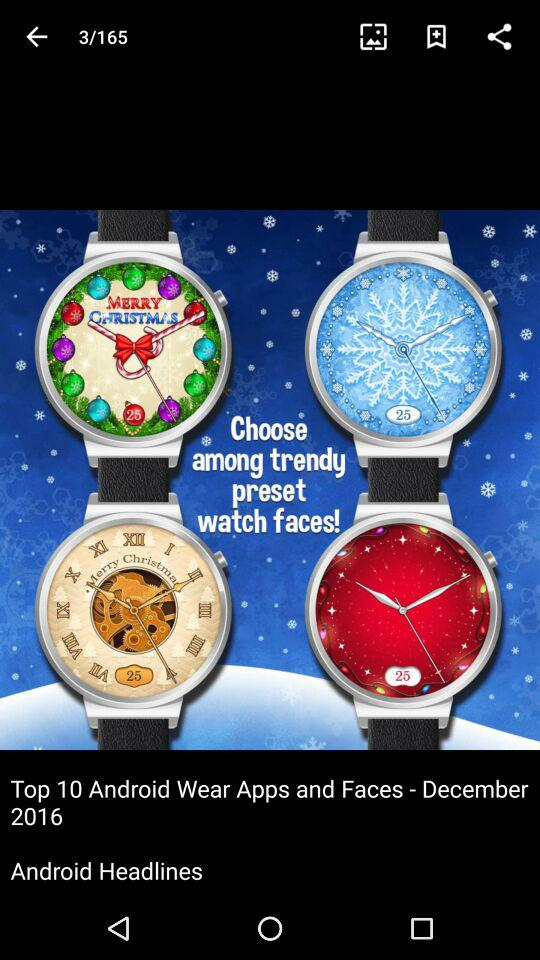What is the headline of the article? The heading of the article is "Top 10 Android Wear Apps and Faces - December 2016". 